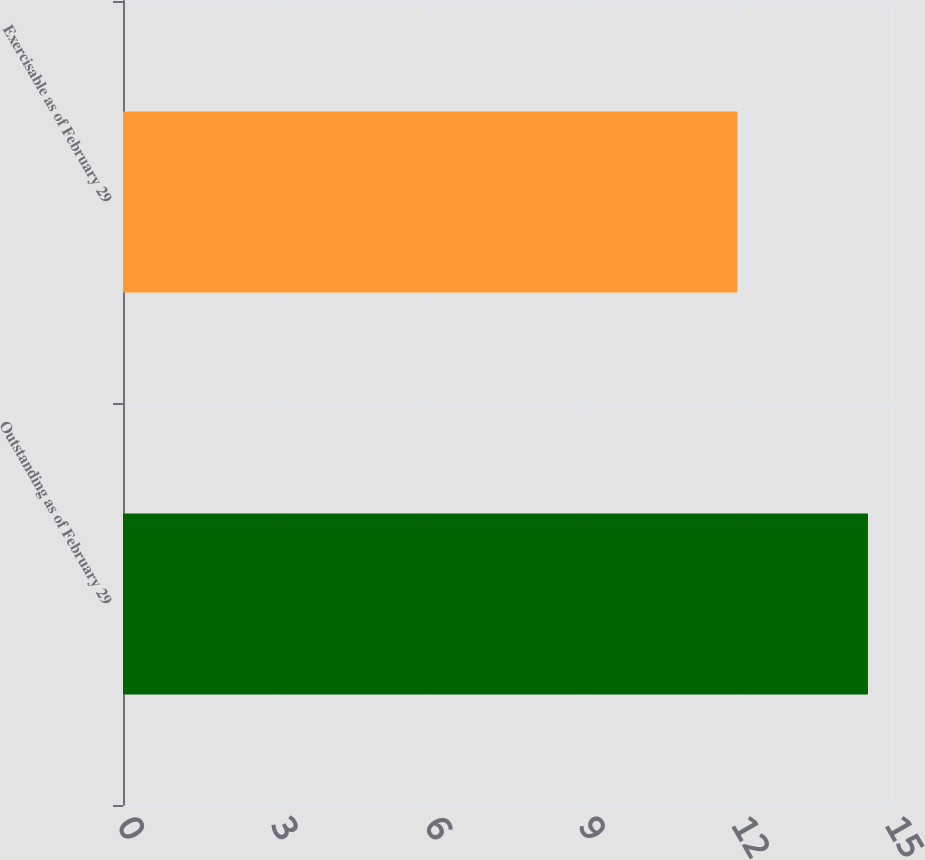Convert chart. <chart><loc_0><loc_0><loc_500><loc_500><bar_chart><fcel>Outstanding as of February 29<fcel>Exercisable as of February 29<nl><fcel>14.55<fcel>12<nl></chart> 